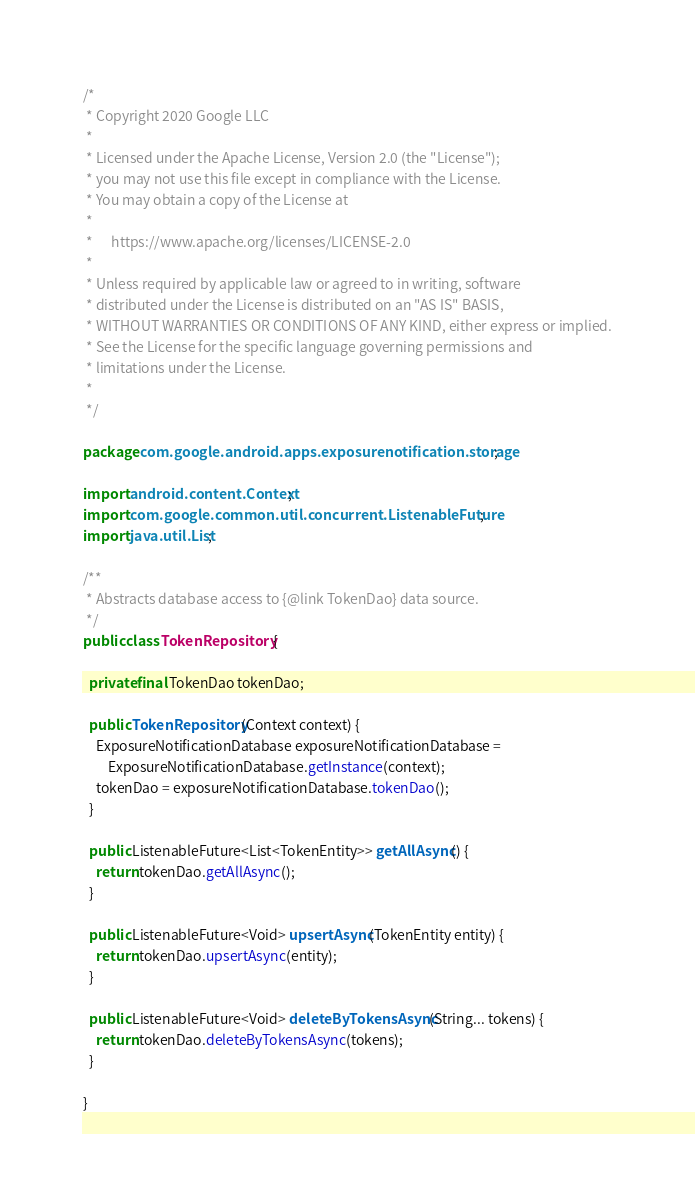Convert code to text. <code><loc_0><loc_0><loc_500><loc_500><_Java_>/*
 * Copyright 2020 Google LLC
 *
 * Licensed under the Apache License, Version 2.0 (the "License");
 * you may not use this file except in compliance with the License.
 * You may obtain a copy of the License at
 *
 *      https://www.apache.org/licenses/LICENSE-2.0
 *
 * Unless required by applicable law or agreed to in writing, software
 * distributed under the License is distributed on an "AS IS" BASIS,
 * WITHOUT WARRANTIES OR CONDITIONS OF ANY KIND, either express or implied.
 * See the License for the specific language governing permissions and
 * limitations under the License.
 *
 */

package com.google.android.apps.exposurenotification.storage;

import android.content.Context;
import com.google.common.util.concurrent.ListenableFuture;
import java.util.List;

/**
 * Abstracts database access to {@link TokenDao} data source.
 */
public class TokenRepository {

  private final TokenDao tokenDao;

  public TokenRepository(Context context) {
    ExposureNotificationDatabase exposureNotificationDatabase =
        ExposureNotificationDatabase.getInstance(context);
    tokenDao = exposureNotificationDatabase.tokenDao();
  }

  public ListenableFuture<List<TokenEntity>> getAllAsync() {
    return tokenDao.getAllAsync();
  }

  public ListenableFuture<Void> upsertAsync(TokenEntity entity) {
    return tokenDao.upsertAsync(entity);
  }

  public ListenableFuture<Void> deleteByTokensAsync(String... tokens) {
    return tokenDao.deleteByTokensAsync(tokens);
  }

}
</code> 